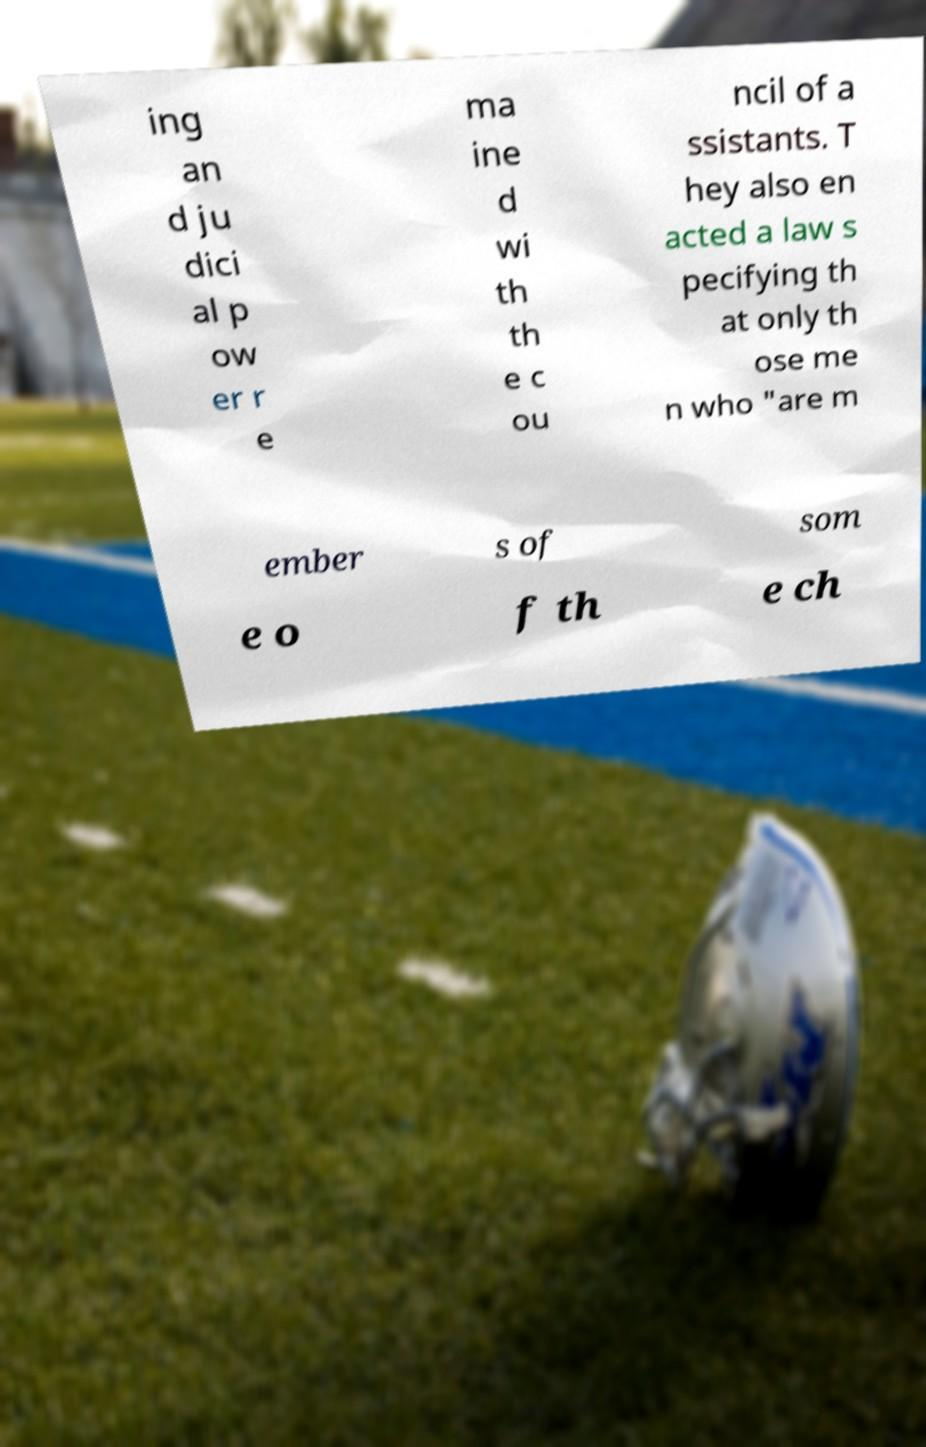Can you read and provide the text displayed in the image?This photo seems to have some interesting text. Can you extract and type it out for me? ing an d ju dici al p ow er r e ma ine d wi th th e c ou ncil of a ssistants. T hey also en acted a law s pecifying th at only th ose me n who "are m ember s of som e o f th e ch 